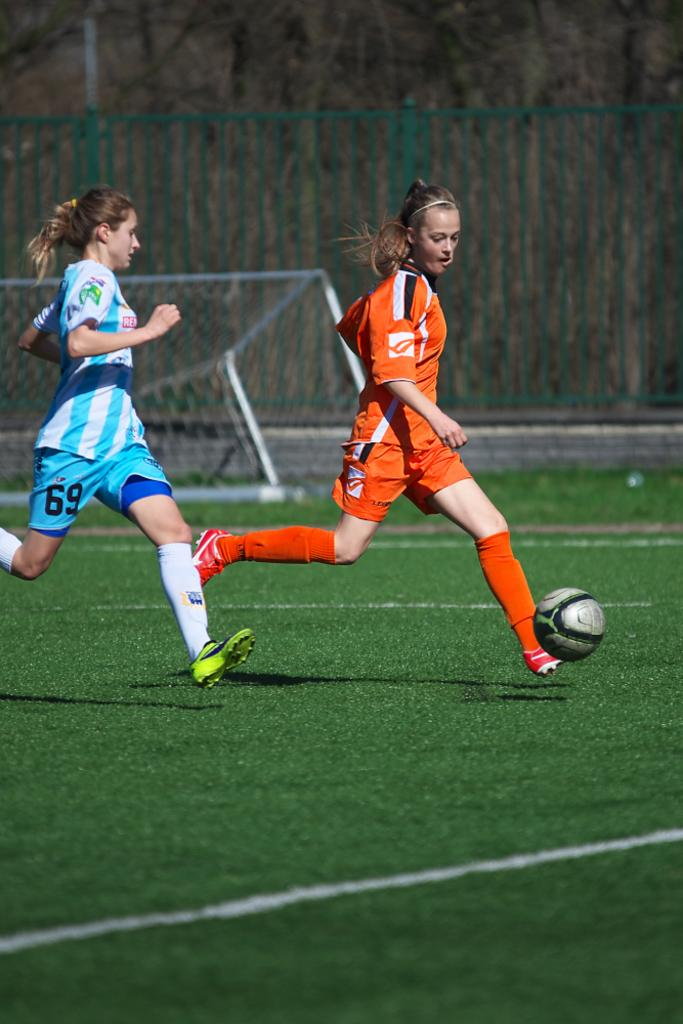<image>
Write a terse but informative summary of the picture. a woman in a 69 shorts tries to get the soccer ball from another 